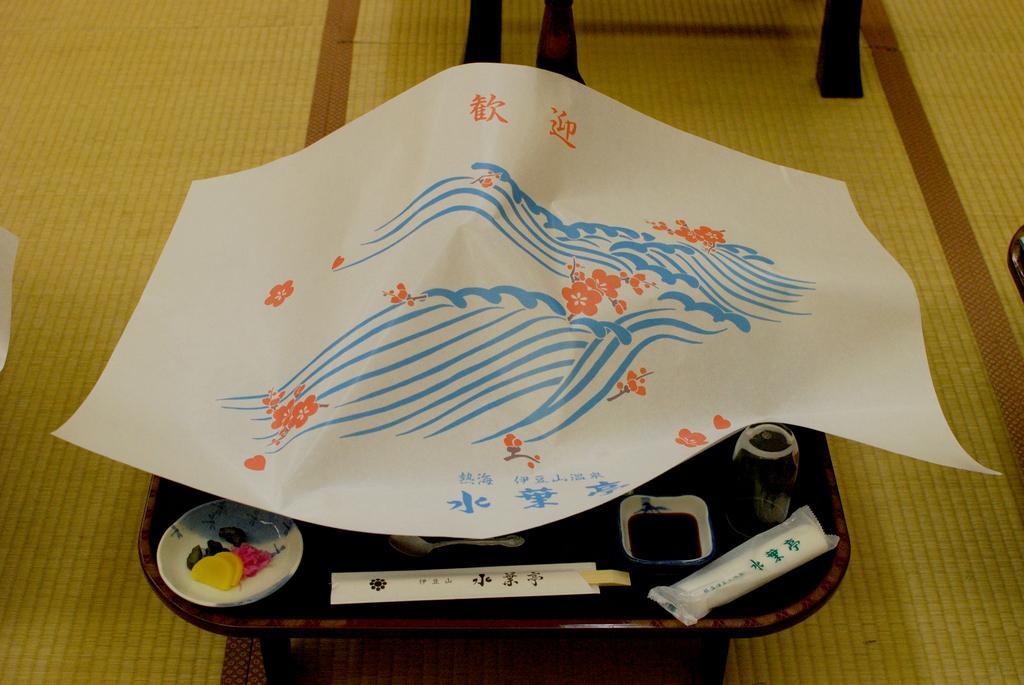How would you summarize this image in a sentence or two? This image consists of a table on which we can see a plate, bowl and a glass. The table is covered with a paper. At the bottom, we can see a floor mat. 